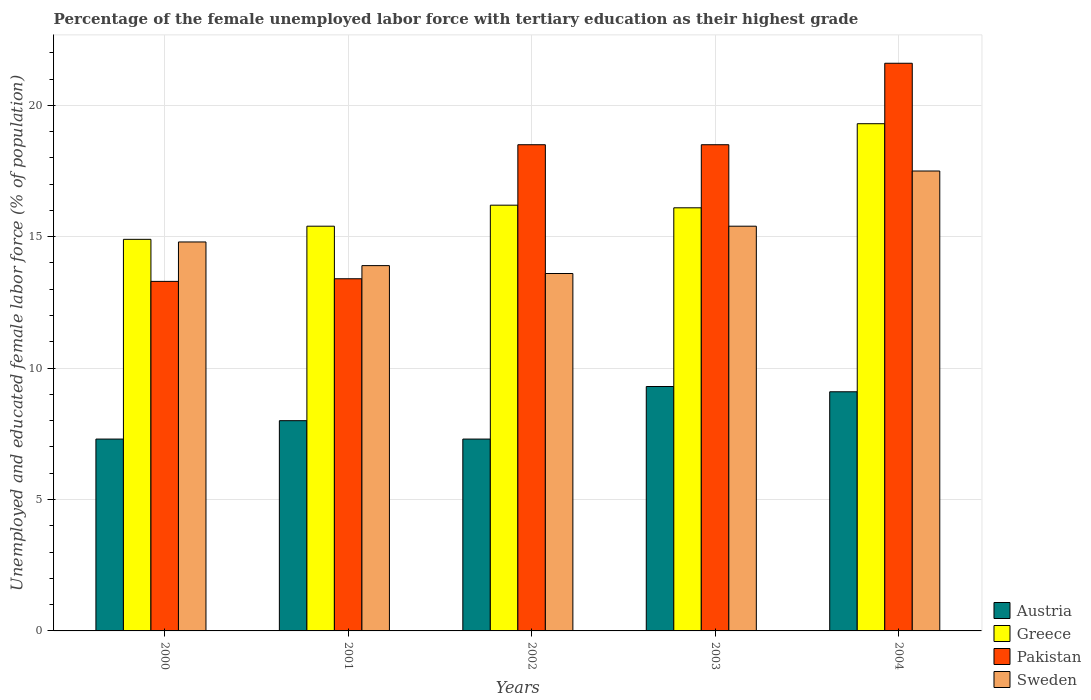How many groups of bars are there?
Your answer should be very brief. 5. Are the number of bars per tick equal to the number of legend labels?
Give a very brief answer. Yes. Are the number of bars on each tick of the X-axis equal?
Offer a very short reply. Yes. How many bars are there on the 2nd tick from the left?
Your answer should be very brief. 4. How many bars are there on the 1st tick from the right?
Provide a succinct answer. 4. What is the label of the 5th group of bars from the left?
Ensure brevity in your answer.  2004. In how many cases, is the number of bars for a given year not equal to the number of legend labels?
Offer a very short reply. 0. What is the percentage of the unemployed female labor force with tertiary education in Greece in 2000?
Offer a very short reply. 14.9. Across all years, what is the maximum percentage of the unemployed female labor force with tertiary education in Pakistan?
Your response must be concise. 21.6. Across all years, what is the minimum percentage of the unemployed female labor force with tertiary education in Greece?
Keep it short and to the point. 14.9. In which year was the percentage of the unemployed female labor force with tertiary education in Greece maximum?
Provide a short and direct response. 2004. In which year was the percentage of the unemployed female labor force with tertiary education in Austria minimum?
Give a very brief answer. 2000. What is the total percentage of the unemployed female labor force with tertiary education in Greece in the graph?
Provide a short and direct response. 81.9. What is the difference between the percentage of the unemployed female labor force with tertiary education in Pakistan in 2001 and that in 2002?
Your answer should be compact. -5.1. What is the difference between the percentage of the unemployed female labor force with tertiary education in Pakistan in 2000 and the percentage of the unemployed female labor force with tertiary education in Greece in 2004?
Offer a terse response. -6. What is the average percentage of the unemployed female labor force with tertiary education in Pakistan per year?
Provide a succinct answer. 17.06. In the year 2000, what is the difference between the percentage of the unemployed female labor force with tertiary education in Greece and percentage of the unemployed female labor force with tertiary education in Austria?
Your response must be concise. 7.6. In how many years, is the percentage of the unemployed female labor force with tertiary education in Austria greater than 2 %?
Your answer should be very brief. 5. What is the ratio of the percentage of the unemployed female labor force with tertiary education in Greece in 2002 to that in 2003?
Offer a terse response. 1.01. Is the percentage of the unemployed female labor force with tertiary education in Greece in 2000 less than that in 2004?
Make the answer very short. Yes. Is the difference between the percentage of the unemployed female labor force with tertiary education in Greece in 2000 and 2002 greater than the difference between the percentage of the unemployed female labor force with tertiary education in Austria in 2000 and 2002?
Make the answer very short. No. What is the difference between the highest and the second highest percentage of the unemployed female labor force with tertiary education in Greece?
Give a very brief answer. 3.1. What is the difference between the highest and the lowest percentage of the unemployed female labor force with tertiary education in Pakistan?
Keep it short and to the point. 8.3. Is it the case that in every year, the sum of the percentage of the unemployed female labor force with tertiary education in Pakistan and percentage of the unemployed female labor force with tertiary education in Austria is greater than the sum of percentage of the unemployed female labor force with tertiary education in Sweden and percentage of the unemployed female labor force with tertiary education in Greece?
Provide a succinct answer. Yes. What does the 1st bar from the left in 2004 represents?
Give a very brief answer. Austria. What does the 3rd bar from the right in 2004 represents?
Your answer should be very brief. Greece. Are all the bars in the graph horizontal?
Make the answer very short. No. How many years are there in the graph?
Offer a terse response. 5. What is the difference between two consecutive major ticks on the Y-axis?
Offer a terse response. 5. Are the values on the major ticks of Y-axis written in scientific E-notation?
Give a very brief answer. No. Does the graph contain grids?
Offer a terse response. Yes. How many legend labels are there?
Provide a short and direct response. 4. What is the title of the graph?
Your response must be concise. Percentage of the female unemployed labor force with tertiary education as their highest grade. What is the label or title of the Y-axis?
Your answer should be very brief. Unemployed and educated female labor force (% of population). What is the Unemployed and educated female labor force (% of population) in Austria in 2000?
Give a very brief answer. 7.3. What is the Unemployed and educated female labor force (% of population) of Greece in 2000?
Your answer should be compact. 14.9. What is the Unemployed and educated female labor force (% of population) of Pakistan in 2000?
Give a very brief answer. 13.3. What is the Unemployed and educated female labor force (% of population) of Sweden in 2000?
Offer a terse response. 14.8. What is the Unemployed and educated female labor force (% of population) in Greece in 2001?
Keep it short and to the point. 15.4. What is the Unemployed and educated female labor force (% of population) of Pakistan in 2001?
Your response must be concise. 13.4. What is the Unemployed and educated female labor force (% of population) in Sweden in 2001?
Provide a succinct answer. 13.9. What is the Unemployed and educated female labor force (% of population) of Austria in 2002?
Offer a very short reply. 7.3. What is the Unemployed and educated female labor force (% of population) in Greece in 2002?
Offer a terse response. 16.2. What is the Unemployed and educated female labor force (% of population) in Pakistan in 2002?
Your response must be concise. 18.5. What is the Unemployed and educated female labor force (% of population) in Sweden in 2002?
Your answer should be very brief. 13.6. What is the Unemployed and educated female labor force (% of population) in Austria in 2003?
Offer a very short reply. 9.3. What is the Unemployed and educated female labor force (% of population) of Greece in 2003?
Give a very brief answer. 16.1. What is the Unemployed and educated female labor force (% of population) of Sweden in 2003?
Your answer should be compact. 15.4. What is the Unemployed and educated female labor force (% of population) of Austria in 2004?
Offer a very short reply. 9.1. What is the Unemployed and educated female labor force (% of population) of Greece in 2004?
Provide a succinct answer. 19.3. What is the Unemployed and educated female labor force (% of population) in Pakistan in 2004?
Keep it short and to the point. 21.6. Across all years, what is the maximum Unemployed and educated female labor force (% of population) of Austria?
Offer a very short reply. 9.3. Across all years, what is the maximum Unemployed and educated female labor force (% of population) of Greece?
Your response must be concise. 19.3. Across all years, what is the maximum Unemployed and educated female labor force (% of population) of Pakistan?
Provide a succinct answer. 21.6. Across all years, what is the maximum Unemployed and educated female labor force (% of population) of Sweden?
Your response must be concise. 17.5. Across all years, what is the minimum Unemployed and educated female labor force (% of population) of Austria?
Ensure brevity in your answer.  7.3. Across all years, what is the minimum Unemployed and educated female labor force (% of population) of Greece?
Make the answer very short. 14.9. Across all years, what is the minimum Unemployed and educated female labor force (% of population) of Pakistan?
Your answer should be very brief. 13.3. Across all years, what is the minimum Unemployed and educated female labor force (% of population) in Sweden?
Provide a succinct answer. 13.6. What is the total Unemployed and educated female labor force (% of population) of Greece in the graph?
Make the answer very short. 81.9. What is the total Unemployed and educated female labor force (% of population) in Pakistan in the graph?
Provide a succinct answer. 85.3. What is the total Unemployed and educated female labor force (% of population) of Sweden in the graph?
Give a very brief answer. 75.2. What is the difference between the Unemployed and educated female labor force (% of population) of Austria in 2000 and that in 2001?
Your answer should be very brief. -0.7. What is the difference between the Unemployed and educated female labor force (% of population) of Pakistan in 2000 and that in 2001?
Offer a terse response. -0.1. What is the difference between the Unemployed and educated female labor force (% of population) in Austria in 2000 and that in 2002?
Give a very brief answer. 0. What is the difference between the Unemployed and educated female labor force (% of population) in Pakistan in 2000 and that in 2002?
Give a very brief answer. -5.2. What is the difference between the Unemployed and educated female labor force (% of population) of Sweden in 2000 and that in 2002?
Your answer should be compact. 1.2. What is the difference between the Unemployed and educated female labor force (% of population) in Pakistan in 2000 and that in 2003?
Offer a terse response. -5.2. What is the difference between the Unemployed and educated female labor force (% of population) in Austria in 2000 and that in 2004?
Offer a very short reply. -1.8. What is the difference between the Unemployed and educated female labor force (% of population) of Sweden in 2000 and that in 2004?
Ensure brevity in your answer.  -2.7. What is the difference between the Unemployed and educated female labor force (% of population) of Austria in 2001 and that in 2002?
Keep it short and to the point. 0.7. What is the difference between the Unemployed and educated female labor force (% of population) in Pakistan in 2001 and that in 2002?
Give a very brief answer. -5.1. What is the difference between the Unemployed and educated female labor force (% of population) of Austria in 2001 and that in 2003?
Ensure brevity in your answer.  -1.3. What is the difference between the Unemployed and educated female labor force (% of population) in Greece in 2001 and that in 2004?
Ensure brevity in your answer.  -3.9. What is the difference between the Unemployed and educated female labor force (% of population) in Pakistan in 2001 and that in 2004?
Your response must be concise. -8.2. What is the difference between the Unemployed and educated female labor force (% of population) of Greece in 2002 and that in 2003?
Your answer should be very brief. 0.1. What is the difference between the Unemployed and educated female labor force (% of population) of Pakistan in 2002 and that in 2003?
Your answer should be compact. 0. What is the difference between the Unemployed and educated female labor force (% of population) of Pakistan in 2002 and that in 2004?
Ensure brevity in your answer.  -3.1. What is the difference between the Unemployed and educated female labor force (% of population) of Sweden in 2002 and that in 2004?
Provide a short and direct response. -3.9. What is the difference between the Unemployed and educated female labor force (% of population) of Pakistan in 2003 and that in 2004?
Provide a short and direct response. -3.1. What is the difference between the Unemployed and educated female labor force (% of population) of Sweden in 2003 and that in 2004?
Your answer should be very brief. -2.1. What is the difference between the Unemployed and educated female labor force (% of population) of Austria in 2000 and the Unemployed and educated female labor force (% of population) of Greece in 2001?
Ensure brevity in your answer.  -8.1. What is the difference between the Unemployed and educated female labor force (% of population) in Greece in 2000 and the Unemployed and educated female labor force (% of population) in Pakistan in 2001?
Your answer should be compact. 1.5. What is the difference between the Unemployed and educated female labor force (% of population) of Austria in 2000 and the Unemployed and educated female labor force (% of population) of Pakistan in 2002?
Offer a terse response. -11.2. What is the difference between the Unemployed and educated female labor force (% of population) of Austria in 2000 and the Unemployed and educated female labor force (% of population) of Sweden in 2002?
Your answer should be very brief. -6.3. What is the difference between the Unemployed and educated female labor force (% of population) of Pakistan in 2000 and the Unemployed and educated female labor force (% of population) of Sweden in 2002?
Offer a very short reply. -0.3. What is the difference between the Unemployed and educated female labor force (% of population) of Austria in 2000 and the Unemployed and educated female labor force (% of population) of Pakistan in 2003?
Keep it short and to the point. -11.2. What is the difference between the Unemployed and educated female labor force (% of population) in Greece in 2000 and the Unemployed and educated female labor force (% of population) in Sweden in 2003?
Offer a terse response. -0.5. What is the difference between the Unemployed and educated female labor force (% of population) in Pakistan in 2000 and the Unemployed and educated female labor force (% of population) in Sweden in 2003?
Offer a terse response. -2.1. What is the difference between the Unemployed and educated female labor force (% of population) in Austria in 2000 and the Unemployed and educated female labor force (% of population) in Pakistan in 2004?
Your response must be concise. -14.3. What is the difference between the Unemployed and educated female labor force (% of population) of Austria in 2000 and the Unemployed and educated female labor force (% of population) of Sweden in 2004?
Provide a short and direct response. -10.2. What is the difference between the Unemployed and educated female labor force (% of population) of Greece in 2000 and the Unemployed and educated female labor force (% of population) of Pakistan in 2004?
Make the answer very short. -6.7. What is the difference between the Unemployed and educated female labor force (% of population) in Pakistan in 2000 and the Unemployed and educated female labor force (% of population) in Sweden in 2004?
Keep it short and to the point. -4.2. What is the difference between the Unemployed and educated female labor force (% of population) in Austria in 2001 and the Unemployed and educated female labor force (% of population) in Greece in 2002?
Ensure brevity in your answer.  -8.2. What is the difference between the Unemployed and educated female labor force (% of population) of Pakistan in 2001 and the Unemployed and educated female labor force (% of population) of Sweden in 2002?
Offer a very short reply. -0.2. What is the difference between the Unemployed and educated female labor force (% of population) in Austria in 2001 and the Unemployed and educated female labor force (% of population) in Greece in 2003?
Provide a succinct answer. -8.1. What is the difference between the Unemployed and educated female labor force (% of population) in Austria in 2001 and the Unemployed and educated female labor force (% of population) in Pakistan in 2003?
Ensure brevity in your answer.  -10.5. What is the difference between the Unemployed and educated female labor force (% of population) in Greece in 2001 and the Unemployed and educated female labor force (% of population) in Pakistan in 2003?
Make the answer very short. -3.1. What is the difference between the Unemployed and educated female labor force (% of population) in Greece in 2001 and the Unemployed and educated female labor force (% of population) in Sweden in 2003?
Keep it short and to the point. 0. What is the difference between the Unemployed and educated female labor force (% of population) of Austria in 2001 and the Unemployed and educated female labor force (% of population) of Greece in 2004?
Your response must be concise. -11.3. What is the difference between the Unemployed and educated female labor force (% of population) of Austria in 2001 and the Unemployed and educated female labor force (% of population) of Sweden in 2004?
Keep it short and to the point. -9.5. What is the difference between the Unemployed and educated female labor force (% of population) of Greece in 2001 and the Unemployed and educated female labor force (% of population) of Pakistan in 2004?
Keep it short and to the point. -6.2. What is the difference between the Unemployed and educated female labor force (% of population) in Austria in 2002 and the Unemployed and educated female labor force (% of population) in Greece in 2003?
Give a very brief answer. -8.8. What is the difference between the Unemployed and educated female labor force (% of population) of Austria in 2002 and the Unemployed and educated female labor force (% of population) of Pakistan in 2003?
Your answer should be compact. -11.2. What is the difference between the Unemployed and educated female labor force (% of population) of Austria in 2002 and the Unemployed and educated female labor force (% of population) of Sweden in 2003?
Make the answer very short. -8.1. What is the difference between the Unemployed and educated female labor force (% of population) of Greece in 2002 and the Unemployed and educated female labor force (% of population) of Pakistan in 2003?
Your answer should be compact. -2.3. What is the difference between the Unemployed and educated female labor force (% of population) in Austria in 2002 and the Unemployed and educated female labor force (% of population) in Pakistan in 2004?
Your answer should be very brief. -14.3. What is the difference between the Unemployed and educated female labor force (% of population) in Greece in 2002 and the Unemployed and educated female labor force (% of population) in Pakistan in 2004?
Your answer should be very brief. -5.4. What is the difference between the Unemployed and educated female labor force (% of population) in Greece in 2002 and the Unemployed and educated female labor force (% of population) in Sweden in 2004?
Your answer should be compact. -1.3. What is the difference between the Unemployed and educated female labor force (% of population) in Pakistan in 2002 and the Unemployed and educated female labor force (% of population) in Sweden in 2004?
Your answer should be compact. 1. What is the difference between the Unemployed and educated female labor force (% of population) in Austria in 2003 and the Unemployed and educated female labor force (% of population) in Greece in 2004?
Your response must be concise. -10. What is the difference between the Unemployed and educated female labor force (% of population) of Austria in 2003 and the Unemployed and educated female labor force (% of population) of Pakistan in 2004?
Make the answer very short. -12.3. What is the difference between the Unemployed and educated female labor force (% of population) of Austria in 2003 and the Unemployed and educated female labor force (% of population) of Sweden in 2004?
Provide a short and direct response. -8.2. What is the difference between the Unemployed and educated female labor force (% of population) of Greece in 2003 and the Unemployed and educated female labor force (% of population) of Sweden in 2004?
Give a very brief answer. -1.4. What is the average Unemployed and educated female labor force (% of population) in Greece per year?
Make the answer very short. 16.38. What is the average Unemployed and educated female labor force (% of population) in Pakistan per year?
Provide a succinct answer. 17.06. What is the average Unemployed and educated female labor force (% of population) in Sweden per year?
Provide a succinct answer. 15.04. In the year 2000, what is the difference between the Unemployed and educated female labor force (% of population) of Austria and Unemployed and educated female labor force (% of population) of Greece?
Your response must be concise. -7.6. In the year 2000, what is the difference between the Unemployed and educated female labor force (% of population) of Austria and Unemployed and educated female labor force (% of population) of Pakistan?
Make the answer very short. -6. In the year 2000, what is the difference between the Unemployed and educated female labor force (% of population) in Greece and Unemployed and educated female labor force (% of population) in Pakistan?
Provide a short and direct response. 1.6. In the year 2000, what is the difference between the Unemployed and educated female labor force (% of population) of Pakistan and Unemployed and educated female labor force (% of population) of Sweden?
Make the answer very short. -1.5. In the year 2001, what is the difference between the Unemployed and educated female labor force (% of population) of Austria and Unemployed and educated female labor force (% of population) of Pakistan?
Your answer should be very brief. -5.4. In the year 2001, what is the difference between the Unemployed and educated female labor force (% of population) of Austria and Unemployed and educated female labor force (% of population) of Sweden?
Provide a succinct answer. -5.9. In the year 2001, what is the difference between the Unemployed and educated female labor force (% of population) of Greece and Unemployed and educated female labor force (% of population) of Sweden?
Keep it short and to the point. 1.5. In the year 2002, what is the difference between the Unemployed and educated female labor force (% of population) of Austria and Unemployed and educated female labor force (% of population) of Greece?
Provide a succinct answer. -8.9. In the year 2002, what is the difference between the Unemployed and educated female labor force (% of population) in Austria and Unemployed and educated female labor force (% of population) in Pakistan?
Ensure brevity in your answer.  -11.2. In the year 2002, what is the difference between the Unemployed and educated female labor force (% of population) of Austria and Unemployed and educated female labor force (% of population) of Sweden?
Your response must be concise. -6.3. In the year 2003, what is the difference between the Unemployed and educated female labor force (% of population) of Austria and Unemployed and educated female labor force (% of population) of Greece?
Ensure brevity in your answer.  -6.8. In the year 2003, what is the difference between the Unemployed and educated female labor force (% of population) of Greece and Unemployed and educated female labor force (% of population) of Pakistan?
Keep it short and to the point. -2.4. In the year 2003, what is the difference between the Unemployed and educated female labor force (% of population) of Greece and Unemployed and educated female labor force (% of population) of Sweden?
Your answer should be compact. 0.7. In the year 2004, what is the difference between the Unemployed and educated female labor force (% of population) in Austria and Unemployed and educated female labor force (% of population) in Sweden?
Provide a short and direct response. -8.4. What is the ratio of the Unemployed and educated female labor force (% of population) in Austria in 2000 to that in 2001?
Offer a terse response. 0.91. What is the ratio of the Unemployed and educated female labor force (% of population) of Greece in 2000 to that in 2001?
Ensure brevity in your answer.  0.97. What is the ratio of the Unemployed and educated female labor force (% of population) of Sweden in 2000 to that in 2001?
Make the answer very short. 1.06. What is the ratio of the Unemployed and educated female labor force (% of population) in Austria in 2000 to that in 2002?
Offer a terse response. 1. What is the ratio of the Unemployed and educated female labor force (% of population) in Greece in 2000 to that in 2002?
Offer a very short reply. 0.92. What is the ratio of the Unemployed and educated female labor force (% of population) of Pakistan in 2000 to that in 2002?
Provide a short and direct response. 0.72. What is the ratio of the Unemployed and educated female labor force (% of population) of Sweden in 2000 to that in 2002?
Give a very brief answer. 1.09. What is the ratio of the Unemployed and educated female labor force (% of population) of Austria in 2000 to that in 2003?
Your answer should be compact. 0.78. What is the ratio of the Unemployed and educated female labor force (% of population) in Greece in 2000 to that in 2003?
Provide a succinct answer. 0.93. What is the ratio of the Unemployed and educated female labor force (% of population) of Pakistan in 2000 to that in 2003?
Offer a very short reply. 0.72. What is the ratio of the Unemployed and educated female labor force (% of population) in Austria in 2000 to that in 2004?
Provide a short and direct response. 0.8. What is the ratio of the Unemployed and educated female labor force (% of population) of Greece in 2000 to that in 2004?
Your response must be concise. 0.77. What is the ratio of the Unemployed and educated female labor force (% of population) in Pakistan in 2000 to that in 2004?
Your response must be concise. 0.62. What is the ratio of the Unemployed and educated female labor force (% of population) in Sweden in 2000 to that in 2004?
Give a very brief answer. 0.85. What is the ratio of the Unemployed and educated female labor force (% of population) in Austria in 2001 to that in 2002?
Provide a succinct answer. 1.1. What is the ratio of the Unemployed and educated female labor force (% of population) in Greece in 2001 to that in 2002?
Your response must be concise. 0.95. What is the ratio of the Unemployed and educated female labor force (% of population) of Pakistan in 2001 to that in 2002?
Your response must be concise. 0.72. What is the ratio of the Unemployed and educated female labor force (% of population) of Sweden in 2001 to that in 2002?
Provide a short and direct response. 1.02. What is the ratio of the Unemployed and educated female labor force (% of population) in Austria in 2001 to that in 2003?
Offer a terse response. 0.86. What is the ratio of the Unemployed and educated female labor force (% of population) of Greece in 2001 to that in 2003?
Provide a succinct answer. 0.96. What is the ratio of the Unemployed and educated female labor force (% of population) of Pakistan in 2001 to that in 2003?
Offer a terse response. 0.72. What is the ratio of the Unemployed and educated female labor force (% of population) in Sweden in 2001 to that in 2003?
Your answer should be very brief. 0.9. What is the ratio of the Unemployed and educated female labor force (% of population) in Austria in 2001 to that in 2004?
Offer a terse response. 0.88. What is the ratio of the Unemployed and educated female labor force (% of population) of Greece in 2001 to that in 2004?
Give a very brief answer. 0.8. What is the ratio of the Unemployed and educated female labor force (% of population) in Pakistan in 2001 to that in 2004?
Your response must be concise. 0.62. What is the ratio of the Unemployed and educated female labor force (% of population) of Sweden in 2001 to that in 2004?
Your answer should be very brief. 0.79. What is the ratio of the Unemployed and educated female labor force (% of population) in Austria in 2002 to that in 2003?
Offer a very short reply. 0.78. What is the ratio of the Unemployed and educated female labor force (% of population) of Greece in 2002 to that in 2003?
Keep it short and to the point. 1.01. What is the ratio of the Unemployed and educated female labor force (% of population) of Pakistan in 2002 to that in 2003?
Make the answer very short. 1. What is the ratio of the Unemployed and educated female labor force (% of population) in Sweden in 2002 to that in 2003?
Offer a terse response. 0.88. What is the ratio of the Unemployed and educated female labor force (% of population) of Austria in 2002 to that in 2004?
Give a very brief answer. 0.8. What is the ratio of the Unemployed and educated female labor force (% of population) of Greece in 2002 to that in 2004?
Make the answer very short. 0.84. What is the ratio of the Unemployed and educated female labor force (% of population) in Pakistan in 2002 to that in 2004?
Offer a terse response. 0.86. What is the ratio of the Unemployed and educated female labor force (% of population) of Sweden in 2002 to that in 2004?
Offer a very short reply. 0.78. What is the ratio of the Unemployed and educated female labor force (% of population) in Greece in 2003 to that in 2004?
Provide a succinct answer. 0.83. What is the ratio of the Unemployed and educated female labor force (% of population) in Pakistan in 2003 to that in 2004?
Your answer should be compact. 0.86. What is the difference between the highest and the lowest Unemployed and educated female labor force (% of population) of Greece?
Offer a very short reply. 4.4. 